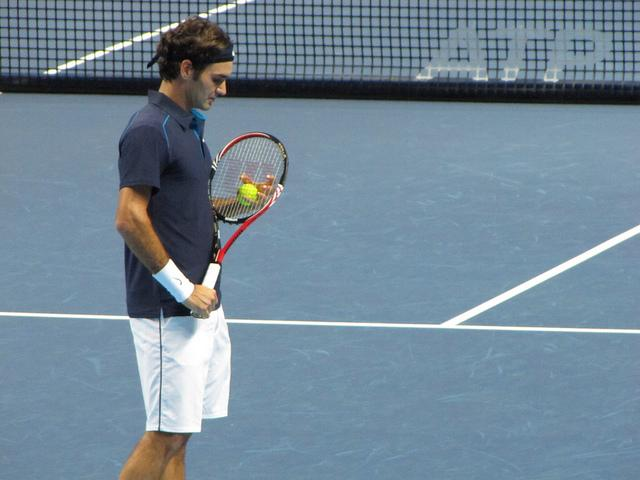What hair accessory is the player wearing to keep his hair out of his face?

Choices:
A) clip
B) bandana
C) sweatband
D) scrunchy sweatband 